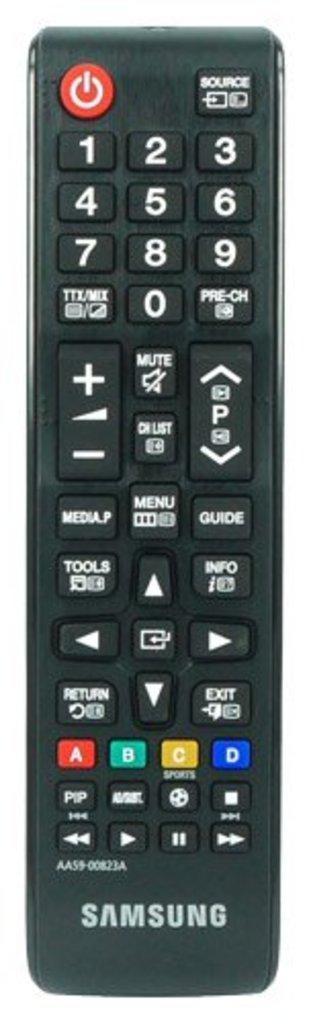Can you describe this image briefly? In the image we can see a TV remote. 